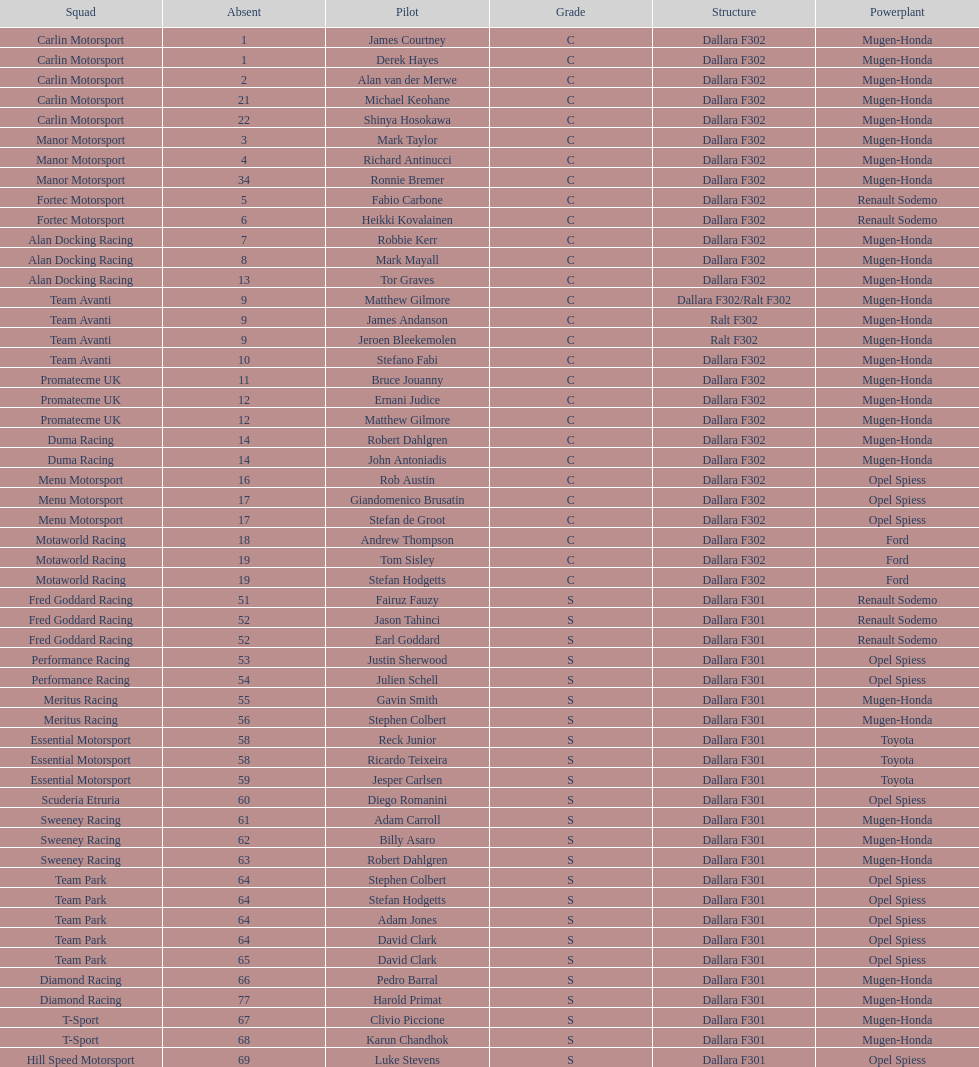How many teams had at least two drivers this season? 17. 